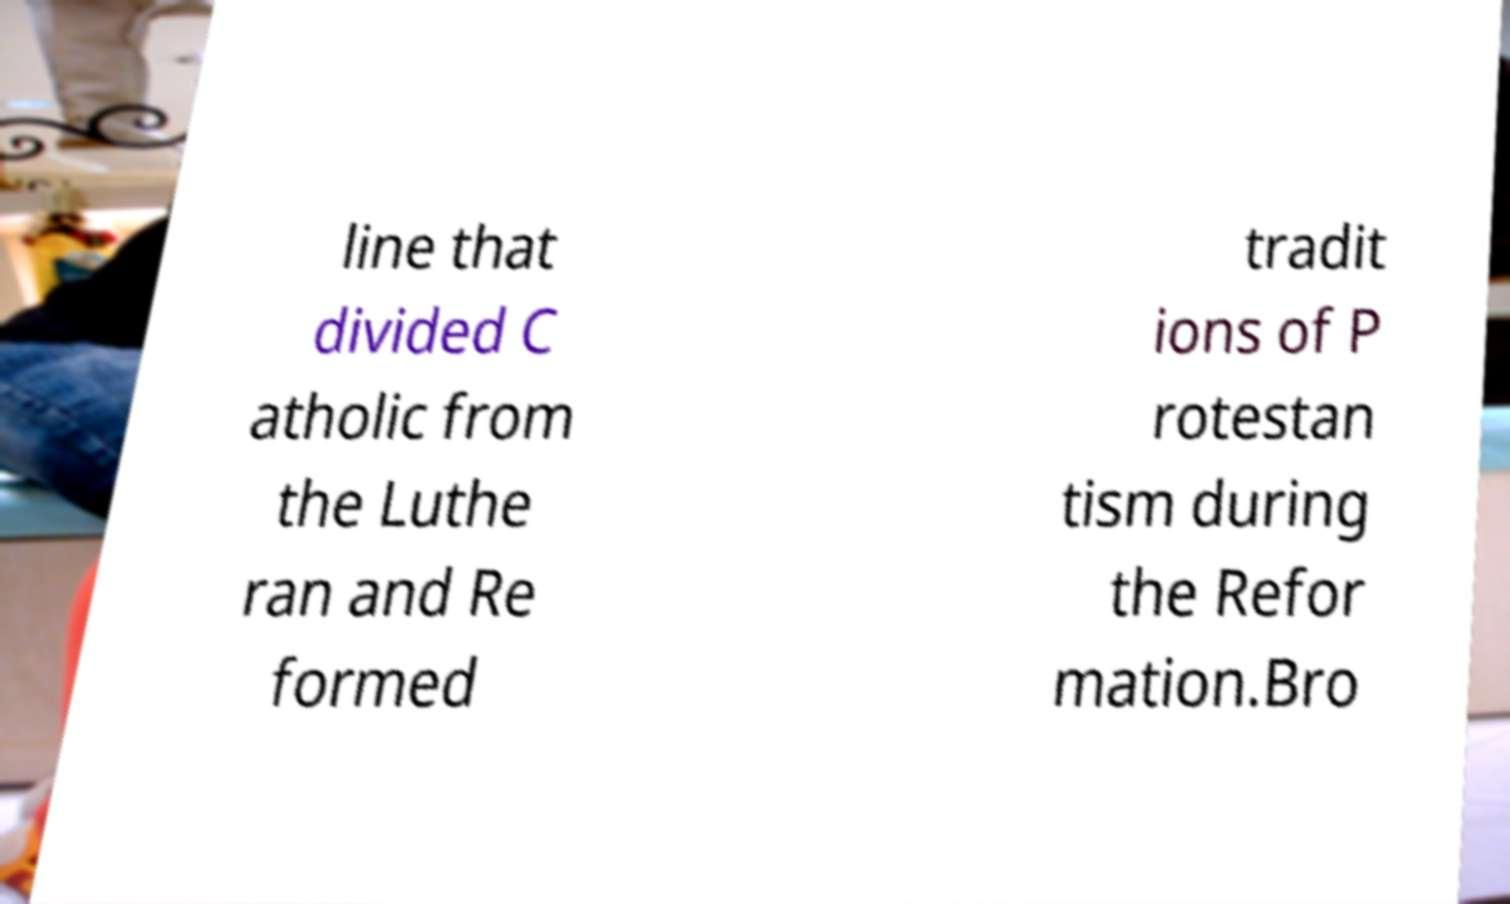Can you read and provide the text displayed in the image?This photo seems to have some interesting text. Can you extract and type it out for me? line that divided C atholic from the Luthe ran and Re formed tradit ions of P rotestan tism during the Refor mation.Bro 